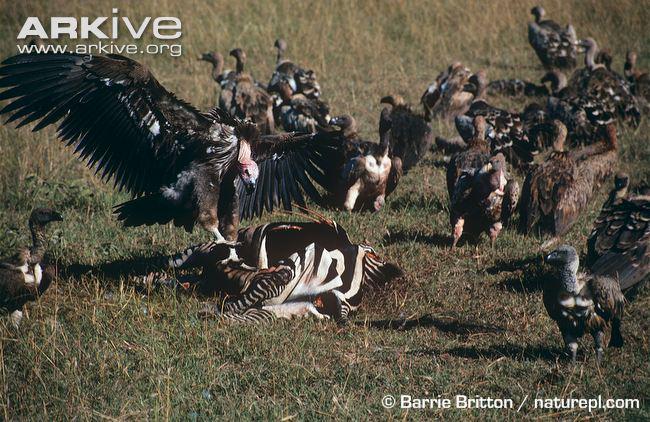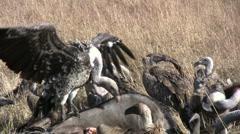The first image is the image on the left, the second image is the image on the right. Analyze the images presented: Is the assertion "The left image contains a carcass being eaten by vultures." valid? Answer yes or no. Yes. The first image is the image on the left, the second image is the image on the right. Considering the images on both sides, is "In at least one image there is a vulture white and black father flying into the ground with his beak open." valid? Answer yes or no. No. 